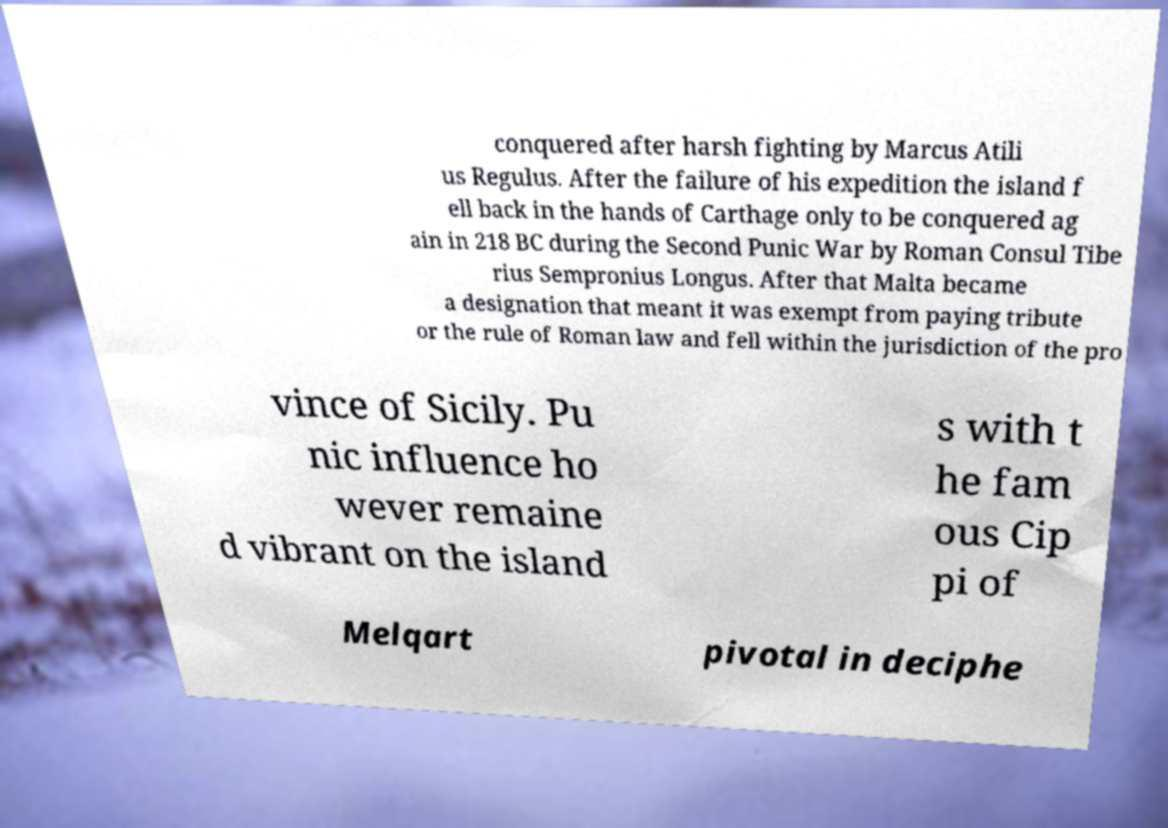Can you read and provide the text displayed in the image?This photo seems to have some interesting text. Can you extract and type it out for me? conquered after harsh fighting by Marcus Atili us Regulus. After the failure of his expedition the island f ell back in the hands of Carthage only to be conquered ag ain in 218 BC during the Second Punic War by Roman Consul Tibe rius Sempronius Longus. After that Malta became a designation that meant it was exempt from paying tribute or the rule of Roman law and fell within the jurisdiction of the pro vince of Sicily. Pu nic influence ho wever remaine d vibrant on the island s with t he fam ous Cip pi of Melqart pivotal in deciphe 